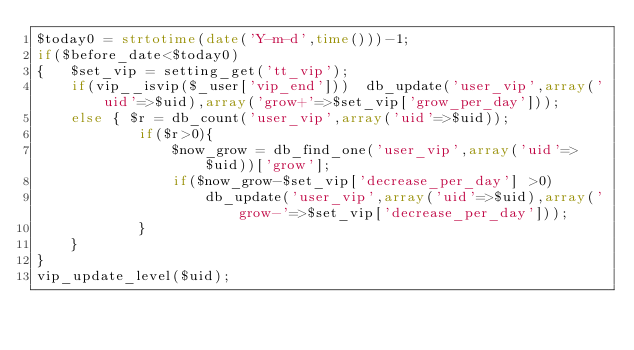<code> <loc_0><loc_0><loc_500><loc_500><_PHP_>$today0 = strtotime(date('Y-m-d',time()))-1;
if($before_date<$today0)
{   $set_vip = setting_get('tt_vip');
    if(vip__isvip($_user['vip_end']))  db_update('user_vip',array('uid'=>$uid),array('grow+'=>$set_vip['grow_per_day']));
    else { $r = db_count('user_vip',array('uid'=>$uid));
            if($r>0){
                $now_grow = db_find_one('user_vip',array('uid'=>$uid))['grow'];
                if($now_grow-$set_vip['decrease_per_day'] >0)
                    db_update('user_vip',array('uid'=>$uid),array('grow-'=>$set_vip['decrease_per_day']));
            }
    }
}
vip_update_level($uid);</code> 